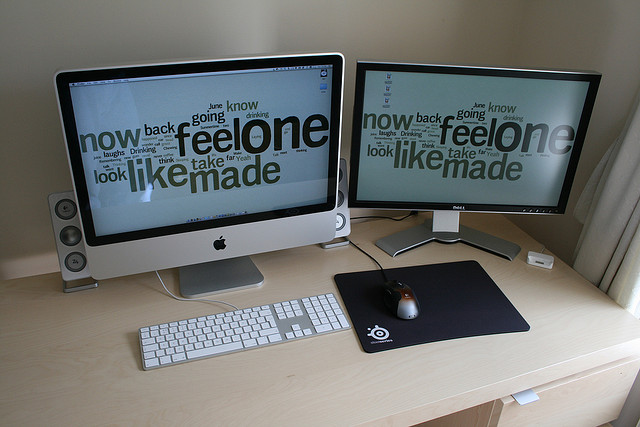Please identify all text content in this image. now back going know emade look like made take know going feelone back now look Drinking drinking June feelone like 